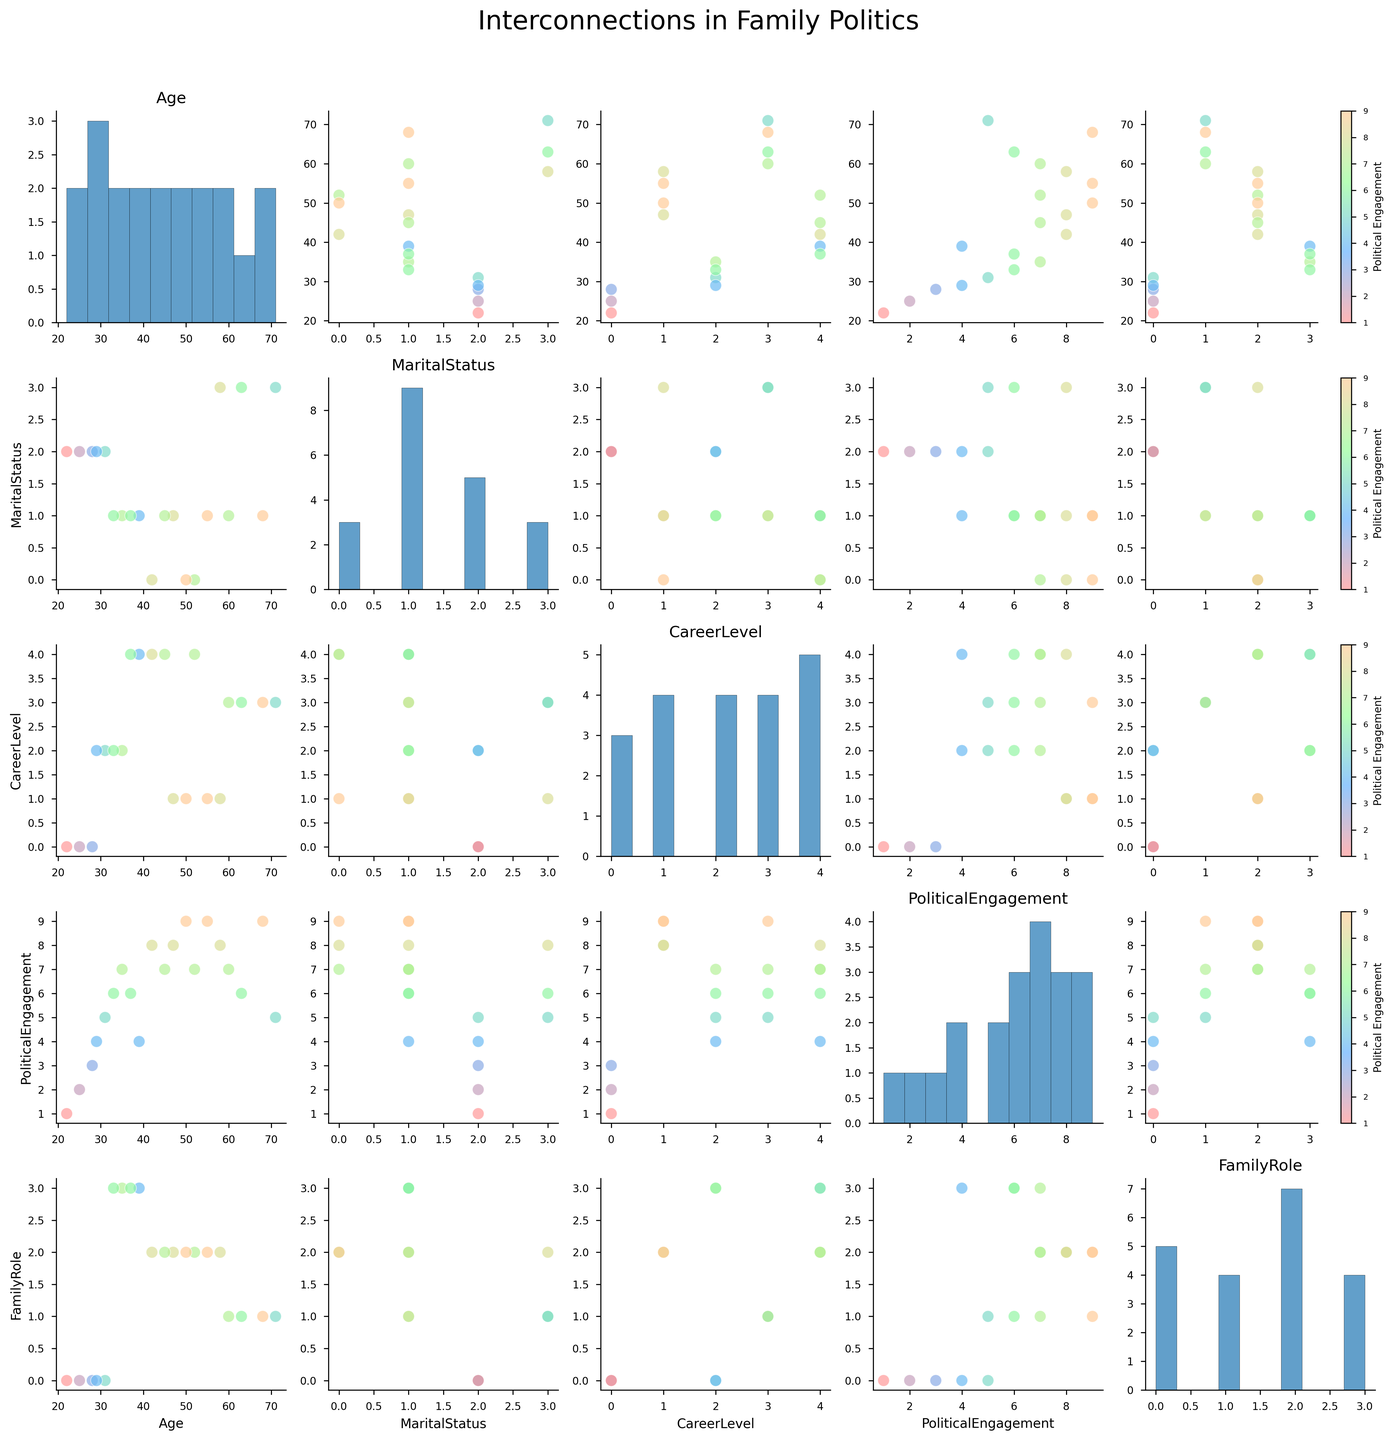What is the title of the figure? The title is the large text that usually appears at the top of a figure, providing an overview of what the figure is about. In this case, the title is "Interconnections in Family Politics" as specified in the generated plot.
Answer: Interconnections in Family Politics Which variable appears on the x-axis for the scatterplot of Age vs. CareerLevel? For the scatterplot in the matrix where Age is plotted against CareerLevel, CareerLevel would be on the x-axis. This setup follows the convention in scatterplot matrices where the variable mentioned second (CareerLevel) is placed on the x-axis.
Answer: CareerLevel Are there any trends observable between Age and PoliticalEngagement? To determine the trend, look at the scatter plots where Age and PoliticalEngagement are involved. PoliticalEngagement is represented by different colors. Generally, higher Age groups seem to have higher PoliticalEngagement values, as older family roles tend to cluster around higher engagement values.
Answer: Yes, older individuals tend to have higher Political Engagement What is the general trend between CareerLevel and PoliticalEngagement? In the scatter plots involving CareerLevel and PoliticalEngagement, higher CareerLevels (mid-level, senior, executive) show higher PoliticalEngagement levels compared to entry-level and retired. This trend can be deduced from plotting PoliticalEngagement on the color scale across the different CareerLevels.
Answer: Higher CareerLevel is associated with higher Political Engagement How many data points represent a Child role? To count the data points representing a Child role, look at the scatterplot matrix and count the points where FamilyRole equals the numeric value assigned to "Child". From the data, Children are represented as 0.
Answer: 5 Which age group has the highest PoliticalEngagement? Examine the scatterplot involving Age and PoliticalEngagement. The highest PoliticalEngagement is 9, and this value seems to be more frequent among older age groups, particularly those above 50.
Answer: Age group above 50 Which FamilyRole has the most varied CareerLevel? Check the scatter plots involving FamilyRole and CareerLevel. Different FamilyRoles like Child, Spouse, Parent, and Grandparent are represented by different values on the FamilyRole axis. Evaluate which FamilyRole shows the widest spread on the CareerLevel axis. Parents exhibit a wide range from mid-level to executive.
Answer: Parent How does MaritalStatus correlate with Age? Look at the scatter plots where MaritalStatus and Age are plotted. Different MaritalStatuses (single, married, divorced, widowed) distributed according to age values. It appears that younger people are more likely to be single, whereas older people are more likely to be widowed or divorced.
Answer: Younger individuals are more likely to be single; older are more likely widowed or divorced Which MaritalStatus group has the highest PoliticalEngagement on average? To determine this, look at the scatter plot of MaritalStatus vs. PoliticalEngagement. Compute the average engagement for each marital status, and note that "Married" individuals cluster around higher engagement values.
Answer: Married 